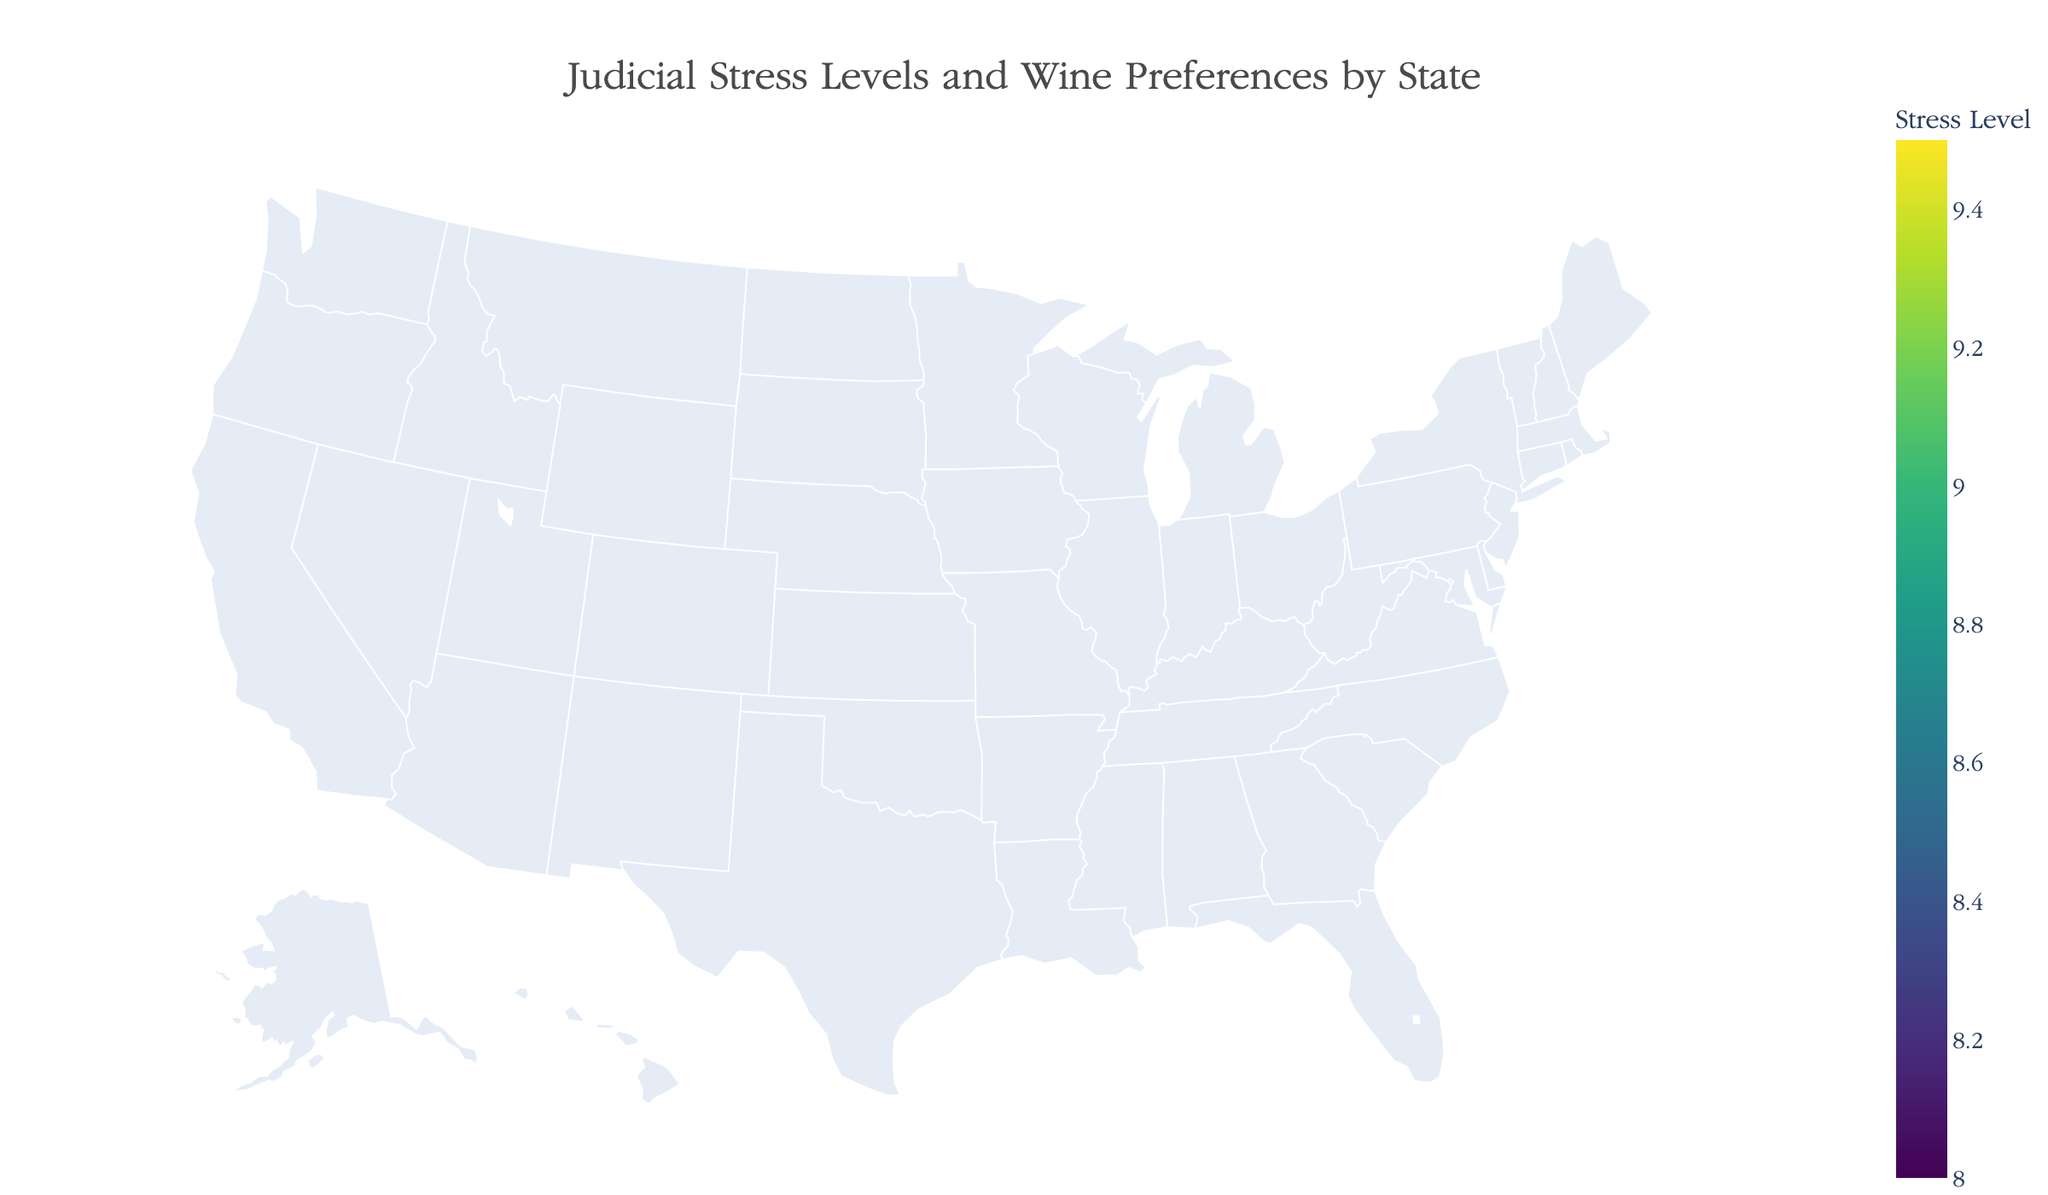What is the title of the plot? The title is located at the top center of the plot. It reads "Judicial Stress Levels and Wine Preferences by State".
Answer: Judicial Stress Levels and Wine Preferences by State Which state has the highest judicial stress level? By observing the color intensity and the hover information, Texas shows the highest judicial stress level with a value of 9.5.
Answer: Texas What is the average caseload in New York? Hovering over New York state reveals the average caseload of judges. The value is 780.
Answer: 780 Which state has the lowest stress level, and what is the corresponding wine variety? By identifying the lightest colored state and using the hover information, Michigan has the lowest stress level of 8.0, and the wine variety is Merlot.
Answer: Michigan, Merlot Compare the judicial stress levels between California and Florida. Which state has a lower level? By comparing the color intensity and values from the hover information, California has a stress level of 9.2 while Florida has 9.3, indicating California has a lower stress level.
Answer: California What is the top wine variety in Texas? Hover over Texas and observe the annotation for the top wine variety. The top wine variety in Texas is Tempranillo.
Answer: Tempranillo How does the average caseload in Arizona compare to that in New Jersey? Hover over Arizona and New Jersey to compare their average caseloads. Arizona has 800, and New Jersey has 760. Arizona has a higher average caseload by 40 cases.
Answer: Arizona has a higher average caseload by 40 cases What's the difference in stress levels between Washington and Georgia? Hover over Washington and Georgia to obtain their stress levels. Washington has a stress level of 8.6, and Georgia has 9.1. The difference is 9.1 - 8.6 = 0.5.
Answer: 0.5 Identify a state with a stress level of 8.7. What is its top wine variety? By examining the plot, Illinois has a stress level of 8.7. The top wine variety in Illinois is Syrah.
Answer: Illinois, Syrah Which state has the closest average caseload to Pennsylvania? Hover over Pennsylvania and other states to compare caseload values. Pennsylvania has 720, and Washington, with 730, has the closest average caseload.
Answer: Washington 